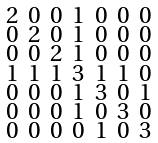Convert formula to latex. <formula><loc_0><loc_0><loc_500><loc_500>\begin{smallmatrix} 2 & 0 & 0 & 1 & 0 & 0 & 0 \\ 0 & 2 & 0 & 1 & 0 & 0 & 0 \\ 0 & 0 & 2 & 1 & 0 & 0 & 0 \\ 1 & 1 & 1 & 3 & 1 & 1 & 0 \\ 0 & 0 & 0 & 1 & 3 & 0 & 1 \\ 0 & 0 & 0 & 1 & 0 & 3 & 0 \\ 0 & 0 & 0 & 0 & 1 & 0 & 3 \end{smallmatrix}</formula> 